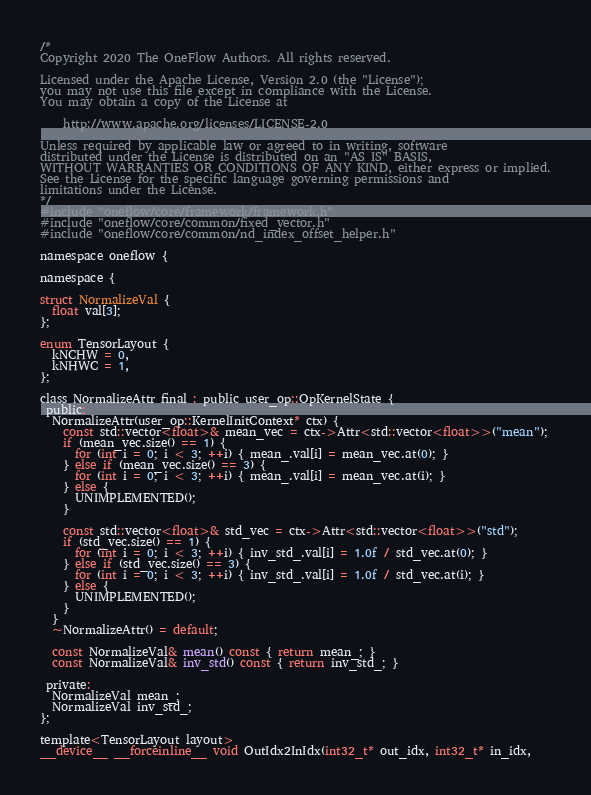<code> <loc_0><loc_0><loc_500><loc_500><_Cuda_>/*
Copyright 2020 The OneFlow Authors. All rights reserved.

Licensed under the Apache License, Version 2.0 (the "License");
you may not use this file except in compliance with the License.
You may obtain a copy of the License at

    http://www.apache.org/licenses/LICENSE-2.0

Unless required by applicable law or agreed to in writing, software
distributed under the License is distributed on an "AS IS" BASIS,
WITHOUT WARRANTIES OR CONDITIONS OF ANY KIND, either express or implied.
See the License for the specific language governing permissions and
limitations under the License.
*/
#include "oneflow/core/framework/framework.h"
#include "oneflow/core/common/fixed_vector.h"
#include "oneflow/core/common/nd_index_offset_helper.h"

namespace oneflow {

namespace {

struct NormalizeVal {
  float val[3];
};

enum TensorLayout {
  kNCHW = 0,
  kNHWC = 1,
};

class NormalizeAttr final : public user_op::OpKernelState {
 public:
  NormalizeAttr(user_op::KernelInitContext* ctx) {
    const std::vector<float>& mean_vec = ctx->Attr<std::vector<float>>("mean");
    if (mean_vec.size() == 1) {
      for (int i = 0; i < 3; ++i) { mean_.val[i] = mean_vec.at(0); }
    } else if (mean_vec.size() == 3) {
      for (int i = 0; i < 3; ++i) { mean_.val[i] = mean_vec.at(i); }
    } else {
      UNIMPLEMENTED();
    }

    const std::vector<float>& std_vec = ctx->Attr<std::vector<float>>("std");
    if (std_vec.size() == 1) {
      for (int i = 0; i < 3; ++i) { inv_std_.val[i] = 1.0f / std_vec.at(0); }
    } else if (std_vec.size() == 3) {
      for (int i = 0; i < 3; ++i) { inv_std_.val[i] = 1.0f / std_vec.at(i); }
    } else {
      UNIMPLEMENTED();
    }
  }
  ~NormalizeAttr() = default;

  const NormalizeVal& mean() const { return mean_; }
  const NormalizeVal& inv_std() const { return inv_std_; }

 private:
  NormalizeVal mean_;
  NormalizeVal inv_std_;
};

template<TensorLayout layout>
__device__ __forceinline__ void OutIdx2InIdx(int32_t* out_idx, int32_t* in_idx,</code> 